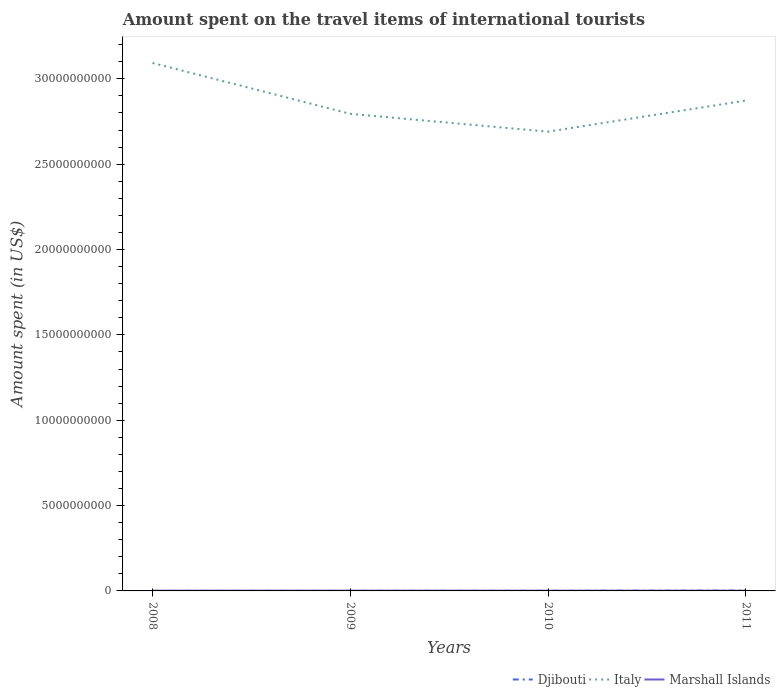How many different coloured lines are there?
Your response must be concise. 3. Does the line corresponding to Italy intersect with the line corresponding to Djibouti?
Your answer should be compact. No. Across all years, what is the maximum amount spent on the travel items of international tourists in Italy?
Give a very brief answer. 2.69e+1. What is the total amount spent on the travel items of international tourists in Djibouti in the graph?
Ensure brevity in your answer.  -1.52e+07. What is the difference between the highest and the second highest amount spent on the travel items of international tourists in Italy?
Keep it short and to the point. 4.02e+09. What is the difference between the highest and the lowest amount spent on the travel items of international tourists in Marshall Islands?
Your answer should be compact. 2. Is the amount spent on the travel items of international tourists in Italy strictly greater than the amount spent on the travel items of international tourists in Marshall Islands over the years?
Provide a short and direct response. No. How many lines are there?
Give a very brief answer. 3. What is the difference between two consecutive major ticks on the Y-axis?
Provide a succinct answer. 5.00e+09. Are the values on the major ticks of Y-axis written in scientific E-notation?
Offer a terse response. No. Where does the legend appear in the graph?
Your response must be concise. Bottom right. What is the title of the graph?
Provide a succinct answer. Amount spent on the travel items of international tourists. Does "Greenland" appear as one of the legend labels in the graph?
Your answer should be compact. No. What is the label or title of the Y-axis?
Offer a very short reply. Amount spent (in US$). What is the Amount spent (in US$) in Djibouti in 2008?
Give a very brief answer. 3.70e+06. What is the Amount spent (in US$) in Italy in 2008?
Provide a short and direct response. 3.09e+1. What is the Amount spent (in US$) of Marshall Islands in 2008?
Provide a short and direct response. 1.16e+07. What is the Amount spent (in US$) in Djibouti in 2009?
Give a very brief answer. 5.80e+06. What is the Amount spent (in US$) in Italy in 2009?
Make the answer very short. 2.80e+1. What is the Amount spent (in US$) of Marshall Islands in 2009?
Your answer should be very brief. 1.24e+07. What is the Amount spent (in US$) in Djibouti in 2010?
Your answer should be very brief. 8.60e+06. What is the Amount spent (in US$) of Italy in 2010?
Offer a terse response. 2.69e+1. What is the Amount spent (in US$) in Marshall Islands in 2010?
Ensure brevity in your answer.  1.11e+07. What is the Amount spent (in US$) of Djibouti in 2011?
Provide a succinct answer. 2.10e+07. What is the Amount spent (in US$) of Italy in 2011?
Ensure brevity in your answer.  2.87e+1. What is the Amount spent (in US$) in Marshall Islands in 2011?
Provide a short and direct response. 1.22e+07. Across all years, what is the maximum Amount spent (in US$) in Djibouti?
Make the answer very short. 2.10e+07. Across all years, what is the maximum Amount spent (in US$) in Italy?
Your answer should be compact. 3.09e+1. Across all years, what is the maximum Amount spent (in US$) of Marshall Islands?
Offer a terse response. 1.24e+07. Across all years, what is the minimum Amount spent (in US$) in Djibouti?
Your answer should be very brief. 3.70e+06. Across all years, what is the minimum Amount spent (in US$) in Italy?
Make the answer very short. 2.69e+1. Across all years, what is the minimum Amount spent (in US$) in Marshall Islands?
Make the answer very short. 1.11e+07. What is the total Amount spent (in US$) in Djibouti in the graph?
Provide a succinct answer. 3.91e+07. What is the total Amount spent (in US$) in Italy in the graph?
Your answer should be very brief. 1.15e+11. What is the total Amount spent (in US$) in Marshall Islands in the graph?
Make the answer very short. 4.73e+07. What is the difference between the Amount spent (in US$) of Djibouti in 2008 and that in 2009?
Provide a succinct answer. -2.10e+06. What is the difference between the Amount spent (in US$) in Italy in 2008 and that in 2009?
Your answer should be compact. 2.98e+09. What is the difference between the Amount spent (in US$) of Marshall Islands in 2008 and that in 2009?
Ensure brevity in your answer.  -7.50e+05. What is the difference between the Amount spent (in US$) in Djibouti in 2008 and that in 2010?
Offer a terse response. -4.90e+06. What is the difference between the Amount spent (in US$) in Italy in 2008 and that in 2010?
Offer a terse response. 4.02e+09. What is the difference between the Amount spent (in US$) of Marshall Islands in 2008 and that in 2010?
Make the answer very short. 5.10e+05. What is the difference between the Amount spent (in US$) of Djibouti in 2008 and that in 2011?
Give a very brief answer. -1.73e+07. What is the difference between the Amount spent (in US$) in Italy in 2008 and that in 2011?
Provide a short and direct response. 2.20e+09. What is the difference between the Amount spent (in US$) of Marshall Islands in 2008 and that in 2011?
Offer a very short reply. -6.30e+05. What is the difference between the Amount spent (in US$) in Djibouti in 2009 and that in 2010?
Your response must be concise. -2.80e+06. What is the difference between the Amount spent (in US$) of Italy in 2009 and that in 2010?
Your answer should be very brief. 1.04e+09. What is the difference between the Amount spent (in US$) of Marshall Islands in 2009 and that in 2010?
Your answer should be compact. 1.26e+06. What is the difference between the Amount spent (in US$) in Djibouti in 2009 and that in 2011?
Offer a terse response. -1.52e+07. What is the difference between the Amount spent (in US$) in Italy in 2009 and that in 2011?
Give a very brief answer. -7.80e+08. What is the difference between the Amount spent (in US$) of Marshall Islands in 2009 and that in 2011?
Your response must be concise. 1.20e+05. What is the difference between the Amount spent (in US$) of Djibouti in 2010 and that in 2011?
Provide a succinct answer. -1.24e+07. What is the difference between the Amount spent (in US$) of Italy in 2010 and that in 2011?
Make the answer very short. -1.82e+09. What is the difference between the Amount spent (in US$) of Marshall Islands in 2010 and that in 2011?
Your answer should be compact. -1.14e+06. What is the difference between the Amount spent (in US$) of Djibouti in 2008 and the Amount spent (in US$) of Italy in 2009?
Offer a terse response. -2.79e+1. What is the difference between the Amount spent (in US$) of Djibouti in 2008 and the Amount spent (in US$) of Marshall Islands in 2009?
Provide a succinct answer. -8.65e+06. What is the difference between the Amount spent (in US$) in Italy in 2008 and the Amount spent (in US$) in Marshall Islands in 2009?
Make the answer very short. 3.09e+1. What is the difference between the Amount spent (in US$) of Djibouti in 2008 and the Amount spent (in US$) of Italy in 2010?
Your answer should be very brief. -2.69e+1. What is the difference between the Amount spent (in US$) in Djibouti in 2008 and the Amount spent (in US$) in Marshall Islands in 2010?
Offer a very short reply. -7.39e+06. What is the difference between the Amount spent (in US$) in Italy in 2008 and the Amount spent (in US$) in Marshall Islands in 2010?
Your response must be concise. 3.09e+1. What is the difference between the Amount spent (in US$) of Djibouti in 2008 and the Amount spent (in US$) of Italy in 2011?
Make the answer very short. -2.87e+1. What is the difference between the Amount spent (in US$) in Djibouti in 2008 and the Amount spent (in US$) in Marshall Islands in 2011?
Your response must be concise. -8.53e+06. What is the difference between the Amount spent (in US$) in Italy in 2008 and the Amount spent (in US$) in Marshall Islands in 2011?
Your answer should be very brief. 3.09e+1. What is the difference between the Amount spent (in US$) of Djibouti in 2009 and the Amount spent (in US$) of Italy in 2010?
Your answer should be very brief. -2.69e+1. What is the difference between the Amount spent (in US$) of Djibouti in 2009 and the Amount spent (in US$) of Marshall Islands in 2010?
Offer a terse response. -5.29e+06. What is the difference between the Amount spent (in US$) in Italy in 2009 and the Amount spent (in US$) in Marshall Islands in 2010?
Your response must be concise. 2.79e+1. What is the difference between the Amount spent (in US$) of Djibouti in 2009 and the Amount spent (in US$) of Italy in 2011?
Your answer should be compact. -2.87e+1. What is the difference between the Amount spent (in US$) in Djibouti in 2009 and the Amount spent (in US$) in Marshall Islands in 2011?
Provide a succinct answer. -6.43e+06. What is the difference between the Amount spent (in US$) of Italy in 2009 and the Amount spent (in US$) of Marshall Islands in 2011?
Provide a short and direct response. 2.79e+1. What is the difference between the Amount spent (in US$) in Djibouti in 2010 and the Amount spent (in US$) in Italy in 2011?
Keep it short and to the point. -2.87e+1. What is the difference between the Amount spent (in US$) in Djibouti in 2010 and the Amount spent (in US$) in Marshall Islands in 2011?
Provide a succinct answer. -3.63e+06. What is the difference between the Amount spent (in US$) in Italy in 2010 and the Amount spent (in US$) in Marshall Islands in 2011?
Give a very brief answer. 2.69e+1. What is the average Amount spent (in US$) of Djibouti per year?
Your answer should be very brief. 9.78e+06. What is the average Amount spent (in US$) in Italy per year?
Provide a succinct answer. 2.86e+1. What is the average Amount spent (in US$) of Marshall Islands per year?
Your answer should be very brief. 1.18e+07. In the year 2008, what is the difference between the Amount spent (in US$) in Djibouti and Amount spent (in US$) in Italy?
Give a very brief answer. -3.09e+1. In the year 2008, what is the difference between the Amount spent (in US$) in Djibouti and Amount spent (in US$) in Marshall Islands?
Your answer should be very brief. -7.90e+06. In the year 2008, what is the difference between the Amount spent (in US$) of Italy and Amount spent (in US$) of Marshall Islands?
Give a very brief answer. 3.09e+1. In the year 2009, what is the difference between the Amount spent (in US$) of Djibouti and Amount spent (in US$) of Italy?
Your response must be concise. -2.79e+1. In the year 2009, what is the difference between the Amount spent (in US$) of Djibouti and Amount spent (in US$) of Marshall Islands?
Ensure brevity in your answer.  -6.55e+06. In the year 2009, what is the difference between the Amount spent (in US$) of Italy and Amount spent (in US$) of Marshall Islands?
Provide a succinct answer. 2.79e+1. In the year 2010, what is the difference between the Amount spent (in US$) of Djibouti and Amount spent (in US$) of Italy?
Your answer should be compact. -2.69e+1. In the year 2010, what is the difference between the Amount spent (in US$) in Djibouti and Amount spent (in US$) in Marshall Islands?
Make the answer very short. -2.49e+06. In the year 2010, what is the difference between the Amount spent (in US$) of Italy and Amount spent (in US$) of Marshall Islands?
Offer a very short reply. 2.69e+1. In the year 2011, what is the difference between the Amount spent (in US$) in Djibouti and Amount spent (in US$) in Italy?
Offer a very short reply. -2.87e+1. In the year 2011, what is the difference between the Amount spent (in US$) of Djibouti and Amount spent (in US$) of Marshall Islands?
Keep it short and to the point. 8.77e+06. In the year 2011, what is the difference between the Amount spent (in US$) in Italy and Amount spent (in US$) in Marshall Islands?
Provide a succinct answer. 2.87e+1. What is the ratio of the Amount spent (in US$) in Djibouti in 2008 to that in 2009?
Provide a short and direct response. 0.64. What is the ratio of the Amount spent (in US$) in Italy in 2008 to that in 2009?
Offer a terse response. 1.11. What is the ratio of the Amount spent (in US$) of Marshall Islands in 2008 to that in 2009?
Offer a terse response. 0.94. What is the ratio of the Amount spent (in US$) in Djibouti in 2008 to that in 2010?
Your answer should be very brief. 0.43. What is the ratio of the Amount spent (in US$) in Italy in 2008 to that in 2010?
Your answer should be compact. 1.15. What is the ratio of the Amount spent (in US$) of Marshall Islands in 2008 to that in 2010?
Provide a short and direct response. 1.05. What is the ratio of the Amount spent (in US$) in Djibouti in 2008 to that in 2011?
Ensure brevity in your answer.  0.18. What is the ratio of the Amount spent (in US$) of Italy in 2008 to that in 2011?
Keep it short and to the point. 1.08. What is the ratio of the Amount spent (in US$) in Marshall Islands in 2008 to that in 2011?
Ensure brevity in your answer.  0.95. What is the ratio of the Amount spent (in US$) of Djibouti in 2009 to that in 2010?
Provide a succinct answer. 0.67. What is the ratio of the Amount spent (in US$) in Italy in 2009 to that in 2010?
Make the answer very short. 1.04. What is the ratio of the Amount spent (in US$) in Marshall Islands in 2009 to that in 2010?
Offer a very short reply. 1.11. What is the ratio of the Amount spent (in US$) in Djibouti in 2009 to that in 2011?
Your answer should be very brief. 0.28. What is the ratio of the Amount spent (in US$) in Italy in 2009 to that in 2011?
Give a very brief answer. 0.97. What is the ratio of the Amount spent (in US$) in Marshall Islands in 2009 to that in 2011?
Your answer should be very brief. 1.01. What is the ratio of the Amount spent (in US$) of Djibouti in 2010 to that in 2011?
Ensure brevity in your answer.  0.41. What is the ratio of the Amount spent (in US$) in Italy in 2010 to that in 2011?
Your response must be concise. 0.94. What is the ratio of the Amount spent (in US$) of Marshall Islands in 2010 to that in 2011?
Make the answer very short. 0.91. What is the difference between the highest and the second highest Amount spent (in US$) in Djibouti?
Make the answer very short. 1.24e+07. What is the difference between the highest and the second highest Amount spent (in US$) in Italy?
Provide a succinct answer. 2.20e+09. What is the difference between the highest and the second highest Amount spent (in US$) in Marshall Islands?
Make the answer very short. 1.20e+05. What is the difference between the highest and the lowest Amount spent (in US$) of Djibouti?
Give a very brief answer. 1.73e+07. What is the difference between the highest and the lowest Amount spent (in US$) of Italy?
Keep it short and to the point. 4.02e+09. What is the difference between the highest and the lowest Amount spent (in US$) of Marshall Islands?
Offer a very short reply. 1.26e+06. 